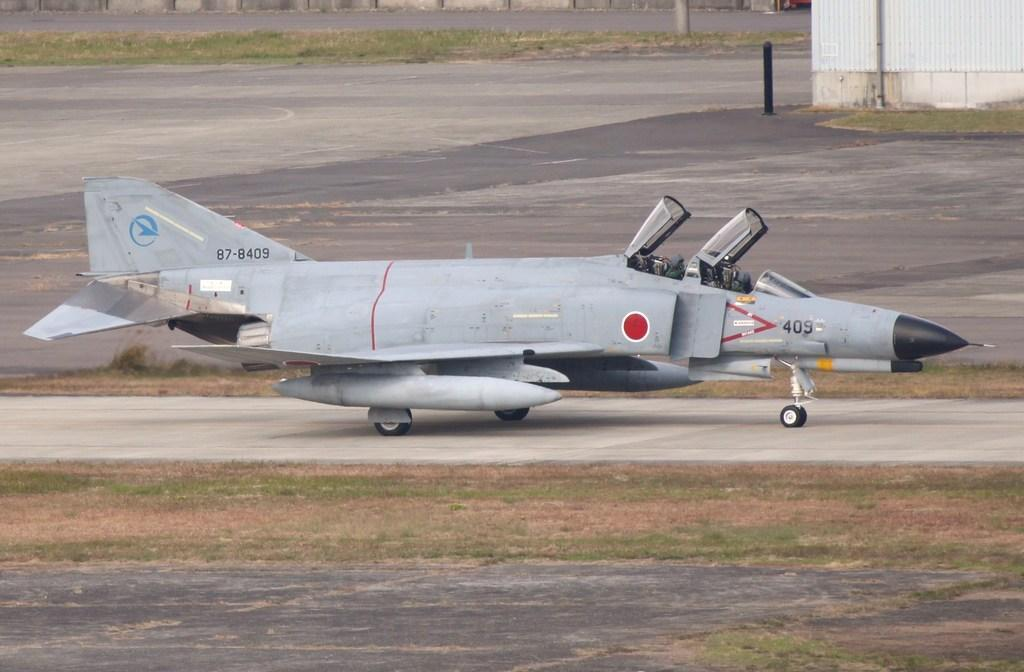What is the main subject of the image? The main subject of the image is an aircraft on the ground. What type of surface is the aircraft resting on? There is grass on the ground in the image. What structures can be seen in the image? Poles are visible in the image. What is located on the right side of the image? There is a wall on the right side of the image. What color is the orange that is being transported on the aircraft in the image? There is no orange present in the image; the main subject is an aircraft on the ground. 